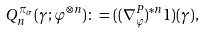Convert formula to latex. <formula><loc_0><loc_0><loc_500><loc_500>Q _ { n } ^ { \pi _ { \sigma } } ( \gamma ; \varphi ^ { \otimes n } ) \colon = ( ( \nabla _ { \varphi } ^ { P } ) ^ { * n } 1 ) ( \gamma ) ,</formula> 